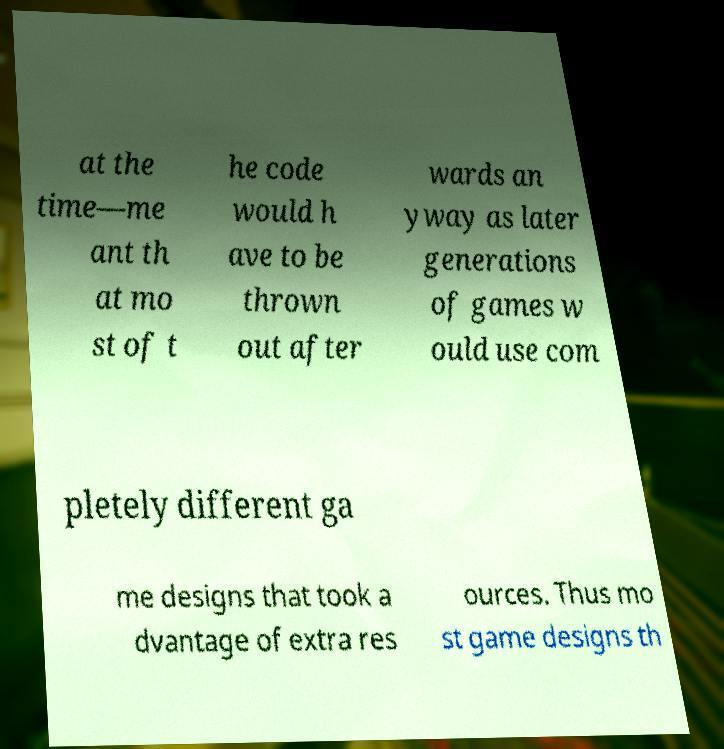For documentation purposes, I need the text within this image transcribed. Could you provide that? at the time—me ant th at mo st of t he code would h ave to be thrown out after wards an yway as later generations of games w ould use com pletely different ga me designs that took a dvantage of extra res ources. Thus mo st game designs th 